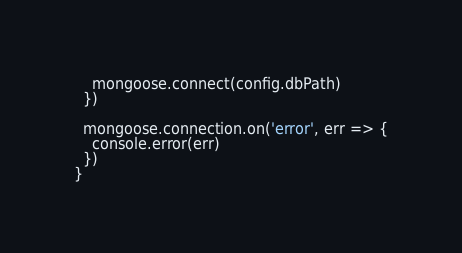Convert code to text. <code><loc_0><loc_0><loc_500><loc_500><_TypeScript_>    mongoose.connect(config.dbPath)
  })

  mongoose.connection.on('error', err => {
    console.error(err)
  })
}
</code> 